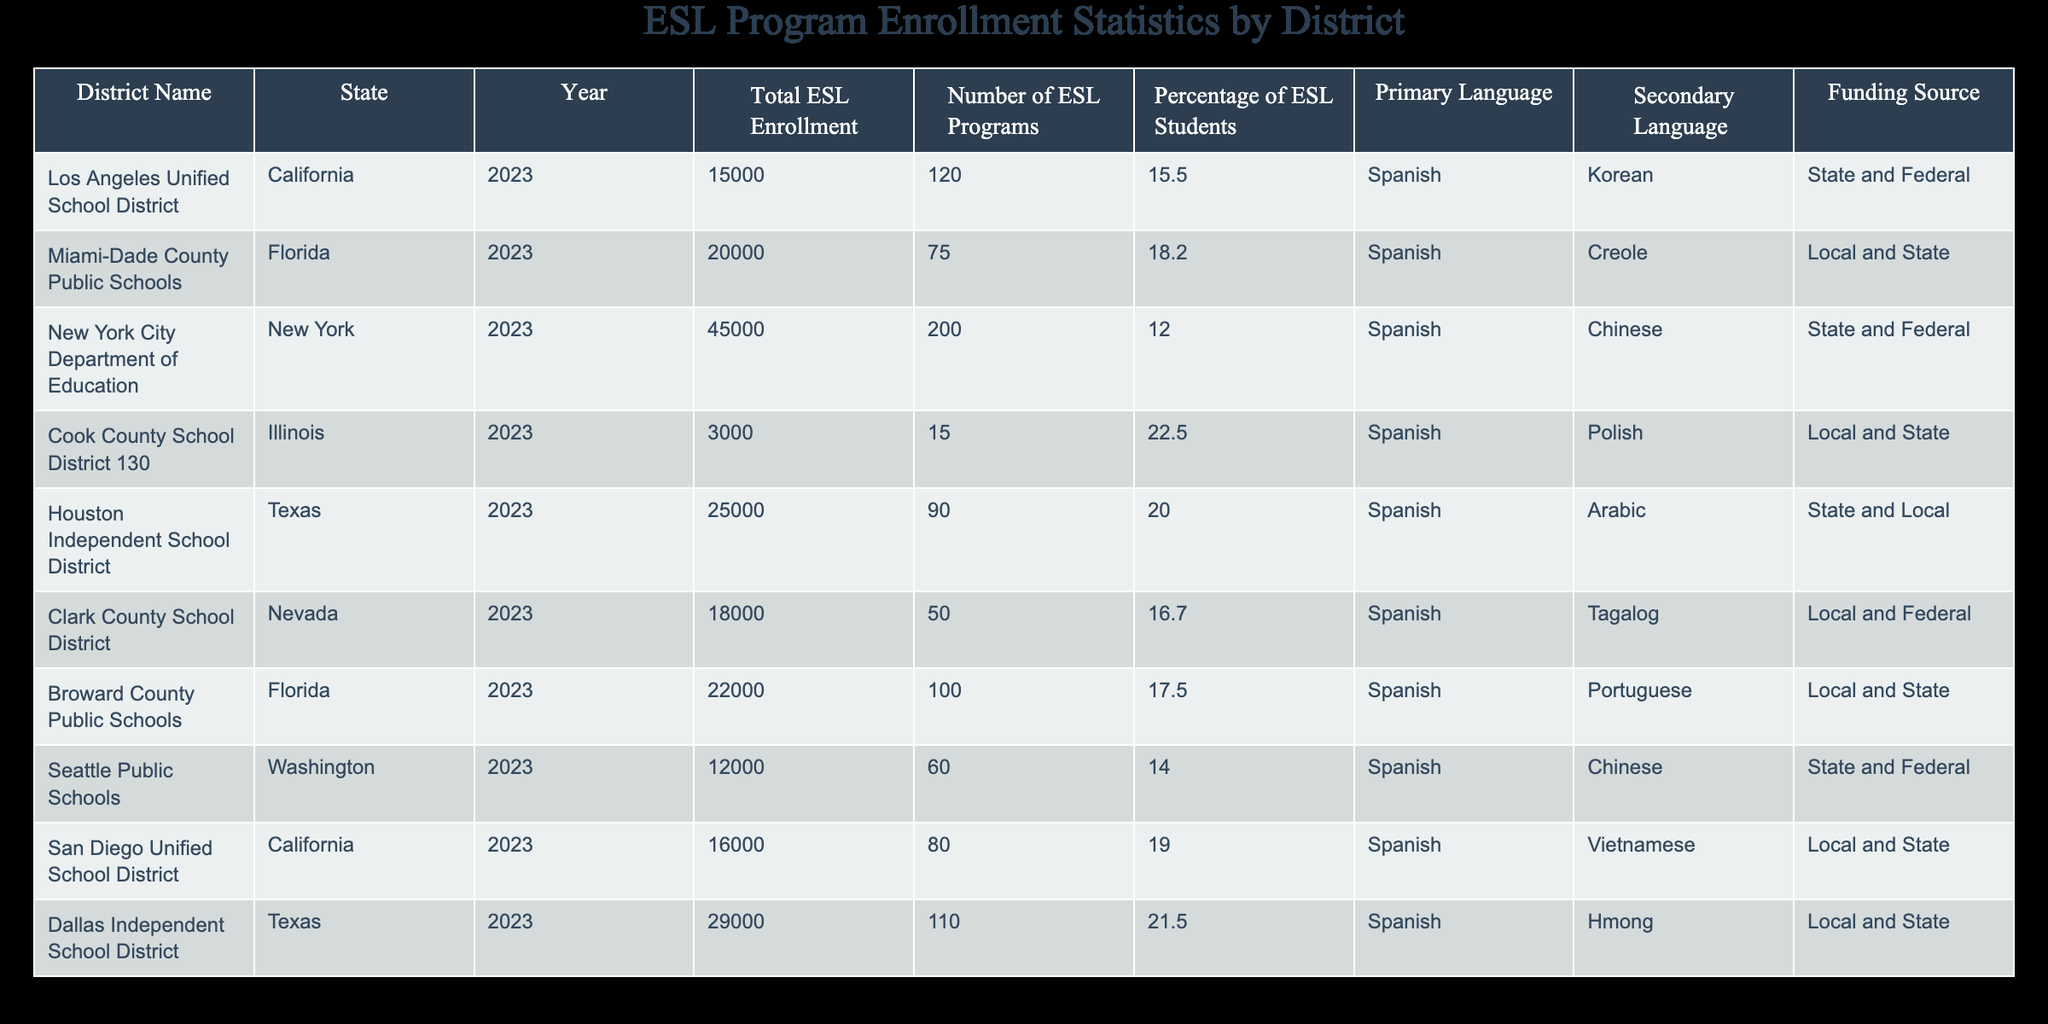What is the total ESL enrollment in New York City Department of Education? The table shows that the total ESL enrollment for New York City Department of Education in 2023 is listed as 45,000.
Answer: 45,000 Which district has the highest percentage of ESL students and what is that percentage? By reviewing the percentage of ESL students across the districts, Cook County School District 130 has the highest percentage at 22.5%.
Answer: 22.5% How many ESL programs are offered by Houston Independent School District? The table indicates that Houston Independent School District has 90 ESL programs available.
Answer: 90 Is the primary language for Clark County School District Spanish? The table states that for Clark County School District, the primary language is Spanish, confirming that the statement is true.
Answer: Yes What is the average total ESL enrollment for districts in Florida? The total ESL enrollments for Florida districts (Miami-Dade County Public Schools with 20,000 and Broward County Public Schools with 22,000) sum to 42,000. Dividing by the number of districts (2), the average is 21,000.
Answer: 21,000 What is the total number of ESL programs for districts in Texas? The districts in Texas (Houston Independent School District with 90 programs and Dallas Independent School District with 110 programs) have a total of 200 ESL programs when summed together (90 + 110 = 200).
Answer: 200 Which district has the least total ESL enrollment and what is the number? The district with the least enrollment is Cook County School District 130, with a total of 3,000 students.
Answer: 3,000 Are there more ESL students enrolled in Seattle Public Schools compared to Los Angeles Unified School District? The enrollment figures show that Seattle Public Schools has 12,000 ESL students while Los Angeles Unified School District has 15,000, indicating that Seattle has fewer students. Therefore, the statement is false.
Answer: No What is the difference in total ESL enrollment between Broward County Public Schools and San Diego Unified School District? Broward County Public Schools has an enrollment of 22,000 and San Diego Unified School District has 16,000. The difference is calculated as 22,000 - 16,000 = 6,000.
Answer: 6,000 